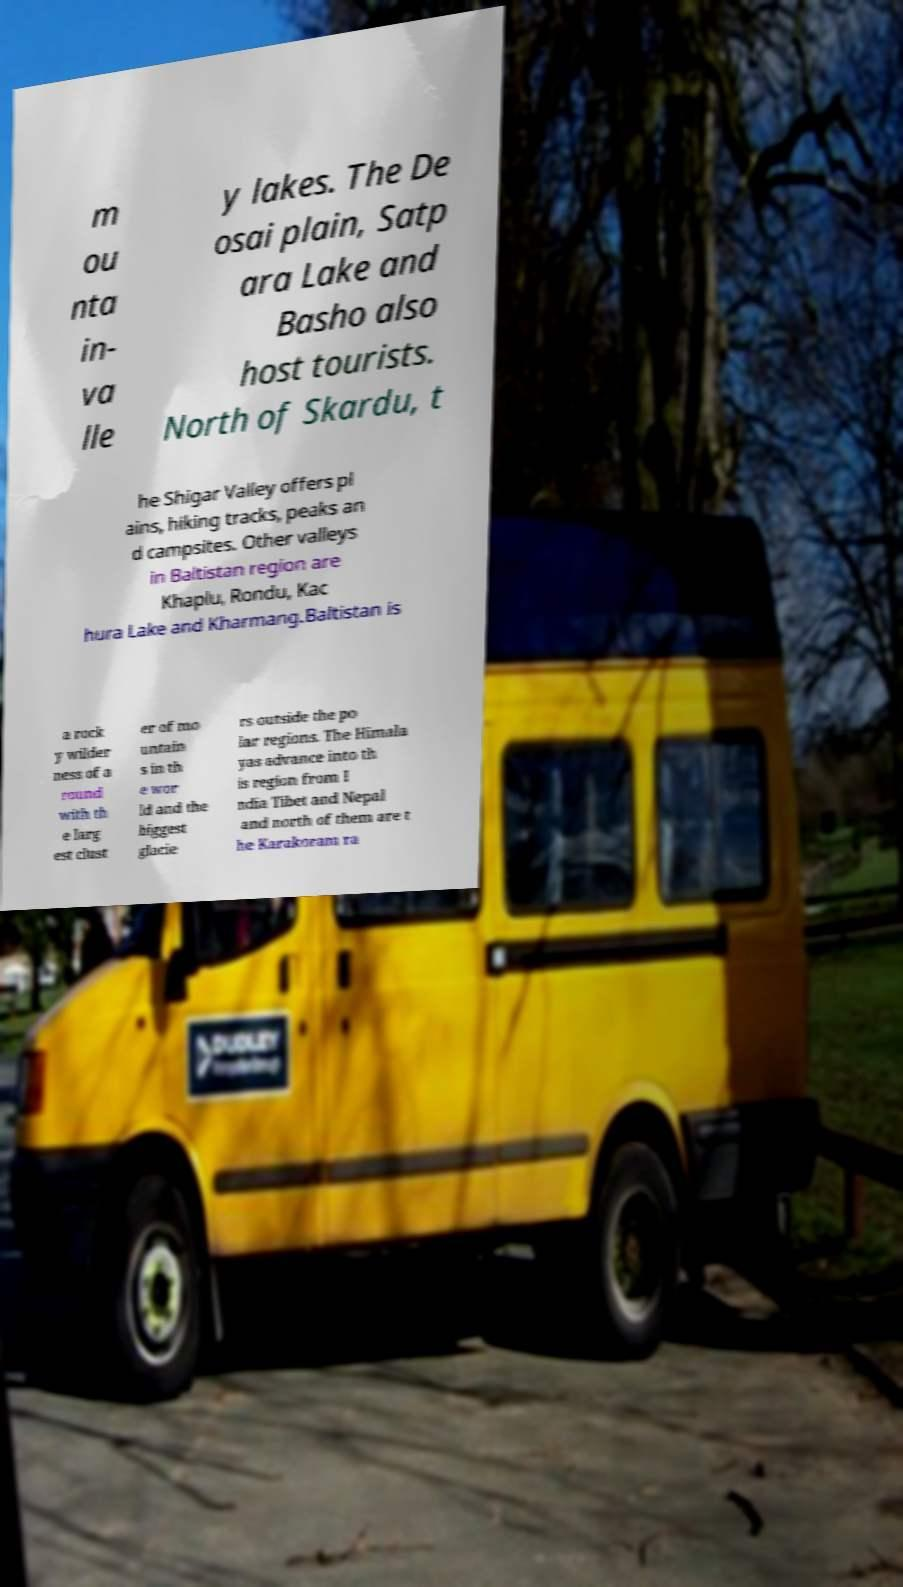Can you accurately transcribe the text from the provided image for me? m ou nta in- va lle y lakes. The De osai plain, Satp ara Lake and Basho also host tourists. North of Skardu, t he Shigar Valley offers pl ains, hiking tracks, peaks an d campsites. Other valleys in Baltistan region are Khaplu, Rondu, Kac hura Lake and Kharmang.Baltistan is a rock y wilder ness of a round with th e larg est clust er of mo untain s in th e wor ld and the biggest glacie rs outside the po lar regions. The Himala yas advance into th is region from I ndia Tibet and Nepal and north of them are t he Karakoram ra 